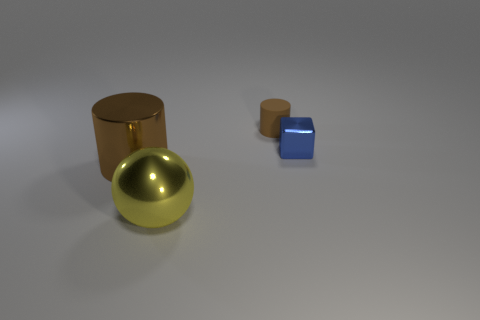Add 3 blue rubber cylinders. How many objects exist? 7 Subtract 1 balls. How many balls are left? 0 Subtract all balls. How many objects are left? 3 Subtract all red cylinders. Subtract all yellow blocks. How many cylinders are left? 2 Subtract all cyan cylinders. How many green spheres are left? 0 Subtract all red metallic cylinders. Subtract all metal cubes. How many objects are left? 3 Add 3 rubber things. How many rubber things are left? 4 Add 3 metal things. How many metal things exist? 6 Subtract 1 yellow spheres. How many objects are left? 3 